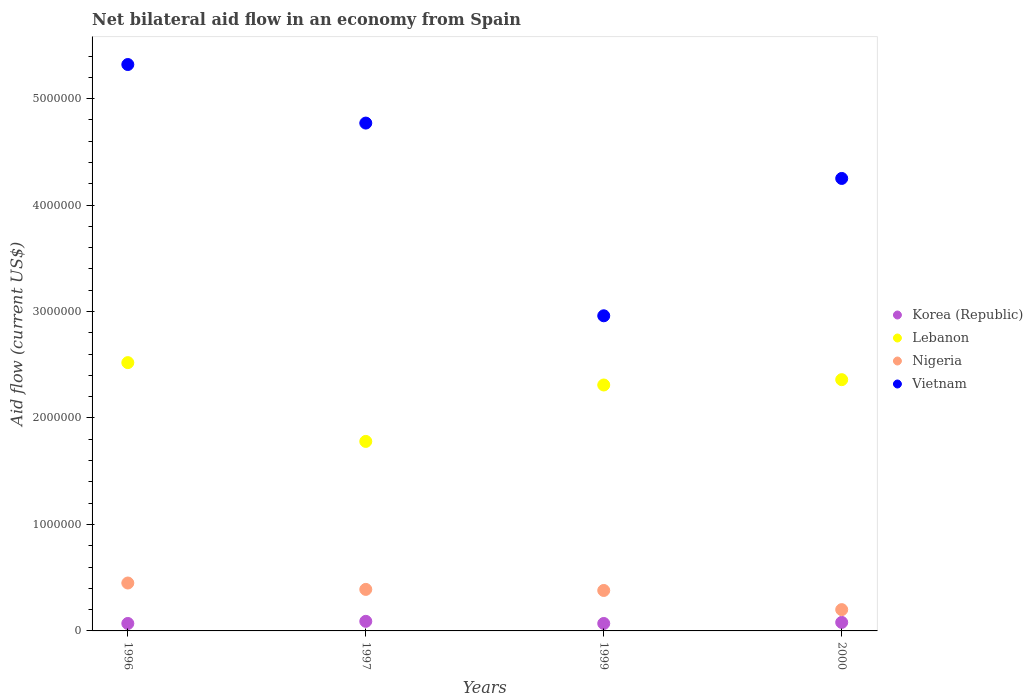How many different coloured dotlines are there?
Your answer should be compact. 4. Is the number of dotlines equal to the number of legend labels?
Offer a very short reply. Yes. What is the net bilateral aid flow in Lebanon in 1996?
Your answer should be compact. 2.52e+06. Across all years, what is the maximum net bilateral aid flow in Nigeria?
Keep it short and to the point. 4.50e+05. In which year was the net bilateral aid flow in Vietnam maximum?
Your answer should be very brief. 1996. What is the total net bilateral aid flow in Korea (Republic) in the graph?
Provide a short and direct response. 3.10e+05. What is the difference between the net bilateral aid flow in Lebanon in 1996 and that in 1999?
Give a very brief answer. 2.10e+05. What is the difference between the net bilateral aid flow in Korea (Republic) in 1997 and the net bilateral aid flow in Vietnam in 2000?
Provide a succinct answer. -4.16e+06. What is the average net bilateral aid flow in Lebanon per year?
Keep it short and to the point. 2.24e+06. In the year 1997, what is the difference between the net bilateral aid flow in Vietnam and net bilateral aid flow in Korea (Republic)?
Offer a very short reply. 4.68e+06. In how many years, is the net bilateral aid flow in Lebanon greater than 1800000 US$?
Offer a terse response. 3. What is the ratio of the net bilateral aid flow in Korea (Republic) in 1996 to that in 1997?
Offer a very short reply. 0.78. Is the net bilateral aid flow in Korea (Republic) in 1999 less than that in 2000?
Keep it short and to the point. Yes. What is the difference between the highest and the lowest net bilateral aid flow in Korea (Republic)?
Offer a very short reply. 2.00e+04. Is the sum of the net bilateral aid flow in Vietnam in 1997 and 2000 greater than the maximum net bilateral aid flow in Nigeria across all years?
Make the answer very short. Yes. Is it the case that in every year, the sum of the net bilateral aid flow in Lebanon and net bilateral aid flow in Korea (Republic)  is greater than the sum of net bilateral aid flow in Vietnam and net bilateral aid flow in Nigeria?
Your response must be concise. Yes. Does the net bilateral aid flow in Nigeria monotonically increase over the years?
Ensure brevity in your answer.  No. Is the net bilateral aid flow in Lebanon strictly greater than the net bilateral aid flow in Vietnam over the years?
Offer a terse response. No. Is the net bilateral aid flow in Nigeria strictly less than the net bilateral aid flow in Lebanon over the years?
Keep it short and to the point. Yes. How many dotlines are there?
Give a very brief answer. 4. How many years are there in the graph?
Keep it short and to the point. 4. Are the values on the major ticks of Y-axis written in scientific E-notation?
Your answer should be compact. No. Does the graph contain any zero values?
Your answer should be compact. No. Does the graph contain grids?
Give a very brief answer. No. Where does the legend appear in the graph?
Make the answer very short. Center right. What is the title of the graph?
Your response must be concise. Net bilateral aid flow in an economy from Spain. Does "Cyprus" appear as one of the legend labels in the graph?
Your response must be concise. No. What is the Aid flow (current US$) of Korea (Republic) in 1996?
Keep it short and to the point. 7.00e+04. What is the Aid flow (current US$) in Lebanon in 1996?
Offer a very short reply. 2.52e+06. What is the Aid flow (current US$) in Vietnam in 1996?
Make the answer very short. 5.32e+06. What is the Aid flow (current US$) in Lebanon in 1997?
Ensure brevity in your answer.  1.78e+06. What is the Aid flow (current US$) of Vietnam in 1997?
Provide a succinct answer. 4.77e+06. What is the Aid flow (current US$) of Lebanon in 1999?
Keep it short and to the point. 2.31e+06. What is the Aid flow (current US$) of Nigeria in 1999?
Your answer should be compact. 3.80e+05. What is the Aid flow (current US$) of Vietnam in 1999?
Provide a short and direct response. 2.96e+06. What is the Aid flow (current US$) in Korea (Republic) in 2000?
Make the answer very short. 8.00e+04. What is the Aid flow (current US$) in Lebanon in 2000?
Provide a succinct answer. 2.36e+06. What is the Aid flow (current US$) of Nigeria in 2000?
Provide a succinct answer. 2.00e+05. What is the Aid flow (current US$) in Vietnam in 2000?
Ensure brevity in your answer.  4.25e+06. Across all years, what is the maximum Aid flow (current US$) of Lebanon?
Provide a short and direct response. 2.52e+06. Across all years, what is the maximum Aid flow (current US$) of Vietnam?
Make the answer very short. 5.32e+06. Across all years, what is the minimum Aid flow (current US$) in Lebanon?
Provide a succinct answer. 1.78e+06. Across all years, what is the minimum Aid flow (current US$) in Vietnam?
Ensure brevity in your answer.  2.96e+06. What is the total Aid flow (current US$) of Korea (Republic) in the graph?
Provide a short and direct response. 3.10e+05. What is the total Aid flow (current US$) of Lebanon in the graph?
Give a very brief answer. 8.97e+06. What is the total Aid flow (current US$) in Nigeria in the graph?
Provide a succinct answer. 1.42e+06. What is the total Aid flow (current US$) of Vietnam in the graph?
Give a very brief answer. 1.73e+07. What is the difference between the Aid flow (current US$) of Lebanon in 1996 and that in 1997?
Your answer should be compact. 7.40e+05. What is the difference between the Aid flow (current US$) of Nigeria in 1996 and that in 1997?
Keep it short and to the point. 6.00e+04. What is the difference between the Aid flow (current US$) in Lebanon in 1996 and that in 1999?
Ensure brevity in your answer.  2.10e+05. What is the difference between the Aid flow (current US$) in Nigeria in 1996 and that in 1999?
Ensure brevity in your answer.  7.00e+04. What is the difference between the Aid flow (current US$) in Vietnam in 1996 and that in 1999?
Your answer should be very brief. 2.36e+06. What is the difference between the Aid flow (current US$) of Korea (Republic) in 1996 and that in 2000?
Ensure brevity in your answer.  -10000. What is the difference between the Aid flow (current US$) in Nigeria in 1996 and that in 2000?
Your answer should be very brief. 2.50e+05. What is the difference between the Aid flow (current US$) of Vietnam in 1996 and that in 2000?
Provide a short and direct response. 1.07e+06. What is the difference between the Aid flow (current US$) of Lebanon in 1997 and that in 1999?
Keep it short and to the point. -5.30e+05. What is the difference between the Aid flow (current US$) in Nigeria in 1997 and that in 1999?
Provide a short and direct response. 10000. What is the difference between the Aid flow (current US$) of Vietnam in 1997 and that in 1999?
Make the answer very short. 1.81e+06. What is the difference between the Aid flow (current US$) in Korea (Republic) in 1997 and that in 2000?
Ensure brevity in your answer.  10000. What is the difference between the Aid flow (current US$) of Lebanon in 1997 and that in 2000?
Provide a succinct answer. -5.80e+05. What is the difference between the Aid flow (current US$) of Vietnam in 1997 and that in 2000?
Your answer should be compact. 5.20e+05. What is the difference between the Aid flow (current US$) in Korea (Republic) in 1999 and that in 2000?
Offer a terse response. -10000. What is the difference between the Aid flow (current US$) in Lebanon in 1999 and that in 2000?
Make the answer very short. -5.00e+04. What is the difference between the Aid flow (current US$) of Nigeria in 1999 and that in 2000?
Your answer should be very brief. 1.80e+05. What is the difference between the Aid flow (current US$) in Vietnam in 1999 and that in 2000?
Offer a terse response. -1.29e+06. What is the difference between the Aid flow (current US$) in Korea (Republic) in 1996 and the Aid flow (current US$) in Lebanon in 1997?
Your response must be concise. -1.71e+06. What is the difference between the Aid flow (current US$) in Korea (Republic) in 1996 and the Aid flow (current US$) in Nigeria in 1997?
Your answer should be very brief. -3.20e+05. What is the difference between the Aid flow (current US$) in Korea (Republic) in 1996 and the Aid flow (current US$) in Vietnam in 1997?
Your response must be concise. -4.70e+06. What is the difference between the Aid flow (current US$) in Lebanon in 1996 and the Aid flow (current US$) in Nigeria in 1997?
Keep it short and to the point. 2.13e+06. What is the difference between the Aid flow (current US$) of Lebanon in 1996 and the Aid flow (current US$) of Vietnam in 1997?
Provide a succinct answer. -2.25e+06. What is the difference between the Aid flow (current US$) of Nigeria in 1996 and the Aid flow (current US$) of Vietnam in 1997?
Your answer should be very brief. -4.32e+06. What is the difference between the Aid flow (current US$) in Korea (Republic) in 1996 and the Aid flow (current US$) in Lebanon in 1999?
Your response must be concise. -2.24e+06. What is the difference between the Aid flow (current US$) in Korea (Republic) in 1996 and the Aid flow (current US$) in Nigeria in 1999?
Give a very brief answer. -3.10e+05. What is the difference between the Aid flow (current US$) in Korea (Republic) in 1996 and the Aid flow (current US$) in Vietnam in 1999?
Your response must be concise. -2.89e+06. What is the difference between the Aid flow (current US$) in Lebanon in 1996 and the Aid flow (current US$) in Nigeria in 1999?
Your response must be concise. 2.14e+06. What is the difference between the Aid flow (current US$) of Lebanon in 1996 and the Aid flow (current US$) of Vietnam in 1999?
Give a very brief answer. -4.40e+05. What is the difference between the Aid flow (current US$) in Nigeria in 1996 and the Aid flow (current US$) in Vietnam in 1999?
Keep it short and to the point. -2.51e+06. What is the difference between the Aid flow (current US$) of Korea (Republic) in 1996 and the Aid flow (current US$) of Lebanon in 2000?
Offer a very short reply. -2.29e+06. What is the difference between the Aid flow (current US$) of Korea (Republic) in 1996 and the Aid flow (current US$) of Vietnam in 2000?
Provide a short and direct response. -4.18e+06. What is the difference between the Aid flow (current US$) in Lebanon in 1996 and the Aid flow (current US$) in Nigeria in 2000?
Keep it short and to the point. 2.32e+06. What is the difference between the Aid flow (current US$) of Lebanon in 1996 and the Aid flow (current US$) of Vietnam in 2000?
Keep it short and to the point. -1.73e+06. What is the difference between the Aid flow (current US$) of Nigeria in 1996 and the Aid flow (current US$) of Vietnam in 2000?
Make the answer very short. -3.80e+06. What is the difference between the Aid flow (current US$) in Korea (Republic) in 1997 and the Aid flow (current US$) in Lebanon in 1999?
Your response must be concise. -2.22e+06. What is the difference between the Aid flow (current US$) in Korea (Republic) in 1997 and the Aid flow (current US$) in Nigeria in 1999?
Provide a succinct answer. -2.90e+05. What is the difference between the Aid flow (current US$) of Korea (Republic) in 1997 and the Aid flow (current US$) of Vietnam in 1999?
Offer a terse response. -2.87e+06. What is the difference between the Aid flow (current US$) in Lebanon in 1997 and the Aid flow (current US$) in Nigeria in 1999?
Provide a succinct answer. 1.40e+06. What is the difference between the Aid flow (current US$) in Lebanon in 1997 and the Aid flow (current US$) in Vietnam in 1999?
Give a very brief answer. -1.18e+06. What is the difference between the Aid flow (current US$) in Nigeria in 1997 and the Aid flow (current US$) in Vietnam in 1999?
Keep it short and to the point. -2.57e+06. What is the difference between the Aid flow (current US$) in Korea (Republic) in 1997 and the Aid flow (current US$) in Lebanon in 2000?
Your response must be concise. -2.27e+06. What is the difference between the Aid flow (current US$) of Korea (Republic) in 1997 and the Aid flow (current US$) of Nigeria in 2000?
Your response must be concise. -1.10e+05. What is the difference between the Aid flow (current US$) of Korea (Republic) in 1997 and the Aid flow (current US$) of Vietnam in 2000?
Provide a short and direct response. -4.16e+06. What is the difference between the Aid flow (current US$) of Lebanon in 1997 and the Aid flow (current US$) of Nigeria in 2000?
Your answer should be very brief. 1.58e+06. What is the difference between the Aid flow (current US$) of Lebanon in 1997 and the Aid flow (current US$) of Vietnam in 2000?
Give a very brief answer. -2.47e+06. What is the difference between the Aid flow (current US$) in Nigeria in 1997 and the Aid flow (current US$) in Vietnam in 2000?
Your response must be concise. -3.86e+06. What is the difference between the Aid flow (current US$) of Korea (Republic) in 1999 and the Aid flow (current US$) of Lebanon in 2000?
Your response must be concise. -2.29e+06. What is the difference between the Aid flow (current US$) in Korea (Republic) in 1999 and the Aid flow (current US$) in Nigeria in 2000?
Keep it short and to the point. -1.30e+05. What is the difference between the Aid flow (current US$) in Korea (Republic) in 1999 and the Aid flow (current US$) in Vietnam in 2000?
Offer a very short reply. -4.18e+06. What is the difference between the Aid flow (current US$) in Lebanon in 1999 and the Aid flow (current US$) in Nigeria in 2000?
Provide a short and direct response. 2.11e+06. What is the difference between the Aid flow (current US$) in Lebanon in 1999 and the Aid flow (current US$) in Vietnam in 2000?
Offer a terse response. -1.94e+06. What is the difference between the Aid flow (current US$) in Nigeria in 1999 and the Aid flow (current US$) in Vietnam in 2000?
Your answer should be very brief. -3.87e+06. What is the average Aid flow (current US$) in Korea (Republic) per year?
Make the answer very short. 7.75e+04. What is the average Aid flow (current US$) of Lebanon per year?
Provide a succinct answer. 2.24e+06. What is the average Aid flow (current US$) of Nigeria per year?
Make the answer very short. 3.55e+05. What is the average Aid flow (current US$) in Vietnam per year?
Provide a short and direct response. 4.32e+06. In the year 1996, what is the difference between the Aid flow (current US$) in Korea (Republic) and Aid flow (current US$) in Lebanon?
Keep it short and to the point. -2.45e+06. In the year 1996, what is the difference between the Aid flow (current US$) in Korea (Republic) and Aid flow (current US$) in Nigeria?
Offer a terse response. -3.80e+05. In the year 1996, what is the difference between the Aid flow (current US$) in Korea (Republic) and Aid flow (current US$) in Vietnam?
Your response must be concise. -5.25e+06. In the year 1996, what is the difference between the Aid flow (current US$) of Lebanon and Aid flow (current US$) of Nigeria?
Provide a succinct answer. 2.07e+06. In the year 1996, what is the difference between the Aid flow (current US$) of Lebanon and Aid flow (current US$) of Vietnam?
Make the answer very short. -2.80e+06. In the year 1996, what is the difference between the Aid flow (current US$) in Nigeria and Aid flow (current US$) in Vietnam?
Give a very brief answer. -4.87e+06. In the year 1997, what is the difference between the Aid flow (current US$) in Korea (Republic) and Aid flow (current US$) in Lebanon?
Your response must be concise. -1.69e+06. In the year 1997, what is the difference between the Aid flow (current US$) in Korea (Republic) and Aid flow (current US$) in Nigeria?
Ensure brevity in your answer.  -3.00e+05. In the year 1997, what is the difference between the Aid flow (current US$) in Korea (Republic) and Aid flow (current US$) in Vietnam?
Provide a succinct answer. -4.68e+06. In the year 1997, what is the difference between the Aid flow (current US$) of Lebanon and Aid flow (current US$) of Nigeria?
Keep it short and to the point. 1.39e+06. In the year 1997, what is the difference between the Aid flow (current US$) of Lebanon and Aid flow (current US$) of Vietnam?
Your answer should be compact. -2.99e+06. In the year 1997, what is the difference between the Aid flow (current US$) in Nigeria and Aid flow (current US$) in Vietnam?
Keep it short and to the point. -4.38e+06. In the year 1999, what is the difference between the Aid flow (current US$) of Korea (Republic) and Aid flow (current US$) of Lebanon?
Keep it short and to the point. -2.24e+06. In the year 1999, what is the difference between the Aid flow (current US$) of Korea (Republic) and Aid flow (current US$) of Nigeria?
Provide a succinct answer. -3.10e+05. In the year 1999, what is the difference between the Aid flow (current US$) in Korea (Republic) and Aid flow (current US$) in Vietnam?
Keep it short and to the point. -2.89e+06. In the year 1999, what is the difference between the Aid flow (current US$) in Lebanon and Aid flow (current US$) in Nigeria?
Offer a terse response. 1.93e+06. In the year 1999, what is the difference between the Aid flow (current US$) in Lebanon and Aid flow (current US$) in Vietnam?
Ensure brevity in your answer.  -6.50e+05. In the year 1999, what is the difference between the Aid flow (current US$) of Nigeria and Aid flow (current US$) of Vietnam?
Your answer should be very brief. -2.58e+06. In the year 2000, what is the difference between the Aid flow (current US$) of Korea (Republic) and Aid flow (current US$) of Lebanon?
Make the answer very short. -2.28e+06. In the year 2000, what is the difference between the Aid flow (current US$) in Korea (Republic) and Aid flow (current US$) in Nigeria?
Offer a very short reply. -1.20e+05. In the year 2000, what is the difference between the Aid flow (current US$) in Korea (Republic) and Aid flow (current US$) in Vietnam?
Offer a terse response. -4.17e+06. In the year 2000, what is the difference between the Aid flow (current US$) of Lebanon and Aid flow (current US$) of Nigeria?
Provide a short and direct response. 2.16e+06. In the year 2000, what is the difference between the Aid flow (current US$) in Lebanon and Aid flow (current US$) in Vietnam?
Make the answer very short. -1.89e+06. In the year 2000, what is the difference between the Aid flow (current US$) of Nigeria and Aid flow (current US$) of Vietnam?
Ensure brevity in your answer.  -4.05e+06. What is the ratio of the Aid flow (current US$) of Korea (Republic) in 1996 to that in 1997?
Your answer should be compact. 0.78. What is the ratio of the Aid flow (current US$) of Lebanon in 1996 to that in 1997?
Give a very brief answer. 1.42. What is the ratio of the Aid flow (current US$) in Nigeria in 1996 to that in 1997?
Provide a short and direct response. 1.15. What is the ratio of the Aid flow (current US$) of Vietnam in 1996 to that in 1997?
Make the answer very short. 1.12. What is the ratio of the Aid flow (current US$) of Korea (Republic) in 1996 to that in 1999?
Ensure brevity in your answer.  1. What is the ratio of the Aid flow (current US$) in Lebanon in 1996 to that in 1999?
Give a very brief answer. 1.09. What is the ratio of the Aid flow (current US$) of Nigeria in 1996 to that in 1999?
Provide a short and direct response. 1.18. What is the ratio of the Aid flow (current US$) in Vietnam in 1996 to that in 1999?
Provide a short and direct response. 1.8. What is the ratio of the Aid flow (current US$) of Korea (Republic) in 1996 to that in 2000?
Ensure brevity in your answer.  0.88. What is the ratio of the Aid flow (current US$) of Lebanon in 1996 to that in 2000?
Ensure brevity in your answer.  1.07. What is the ratio of the Aid flow (current US$) in Nigeria in 1996 to that in 2000?
Ensure brevity in your answer.  2.25. What is the ratio of the Aid flow (current US$) of Vietnam in 1996 to that in 2000?
Provide a short and direct response. 1.25. What is the ratio of the Aid flow (current US$) in Korea (Republic) in 1997 to that in 1999?
Provide a short and direct response. 1.29. What is the ratio of the Aid flow (current US$) in Lebanon in 1997 to that in 1999?
Your answer should be compact. 0.77. What is the ratio of the Aid flow (current US$) of Nigeria in 1997 to that in 1999?
Your answer should be compact. 1.03. What is the ratio of the Aid flow (current US$) of Vietnam in 1997 to that in 1999?
Your response must be concise. 1.61. What is the ratio of the Aid flow (current US$) of Lebanon in 1997 to that in 2000?
Give a very brief answer. 0.75. What is the ratio of the Aid flow (current US$) of Nigeria in 1997 to that in 2000?
Make the answer very short. 1.95. What is the ratio of the Aid flow (current US$) in Vietnam in 1997 to that in 2000?
Ensure brevity in your answer.  1.12. What is the ratio of the Aid flow (current US$) of Korea (Republic) in 1999 to that in 2000?
Make the answer very short. 0.88. What is the ratio of the Aid flow (current US$) in Lebanon in 1999 to that in 2000?
Ensure brevity in your answer.  0.98. What is the ratio of the Aid flow (current US$) in Vietnam in 1999 to that in 2000?
Give a very brief answer. 0.7. What is the difference between the highest and the second highest Aid flow (current US$) of Korea (Republic)?
Make the answer very short. 10000. What is the difference between the highest and the second highest Aid flow (current US$) of Nigeria?
Ensure brevity in your answer.  6.00e+04. What is the difference between the highest and the lowest Aid flow (current US$) of Lebanon?
Provide a short and direct response. 7.40e+05. What is the difference between the highest and the lowest Aid flow (current US$) of Nigeria?
Give a very brief answer. 2.50e+05. What is the difference between the highest and the lowest Aid flow (current US$) in Vietnam?
Your response must be concise. 2.36e+06. 